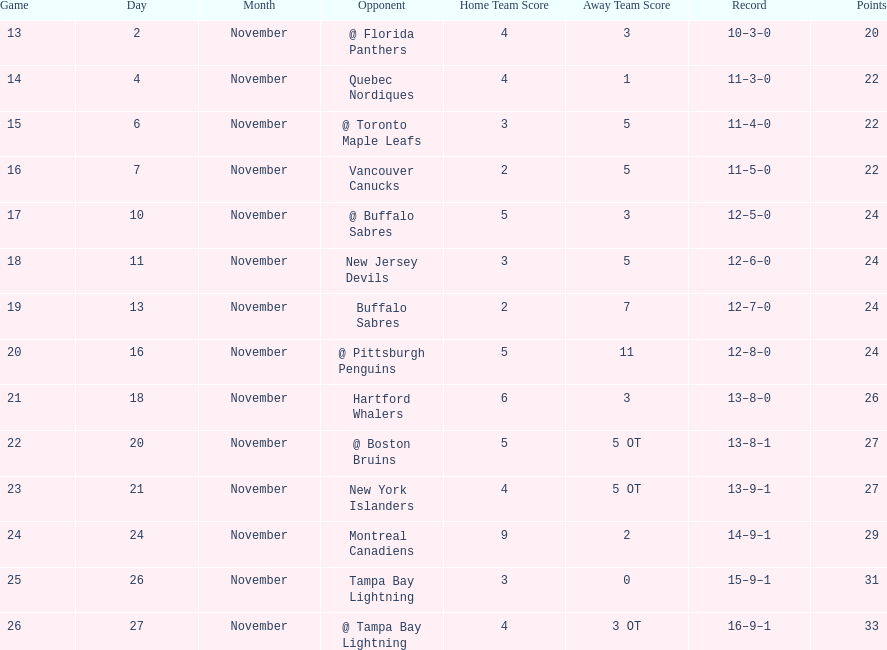Would you mind parsing the complete table? {'header': ['Game', 'Day', 'Month', 'Opponent', 'Home Team Score', 'Away Team Score', 'Record', 'Points'], 'rows': [['13', '2', 'November', '@ Florida Panthers', '4', '3', '10–3–0', '20'], ['14', '4', 'November', 'Quebec Nordiques', '4', '1', '11–3–0', '22'], ['15', '6', 'November', '@ Toronto Maple Leafs', '3', '5', '11–4–0', '22'], ['16', '7', 'November', 'Vancouver Canucks', '2', '5', '11–5–0', '22'], ['17', '10', 'November', '@ Buffalo Sabres', '5', '3', '12–5–0', '24'], ['18', '11', 'November', 'New Jersey Devils', '3', '5', '12–6–0', '24'], ['19', '13', 'November', 'Buffalo Sabres', '2', '7', '12–7–0', '24'], ['20', '16', 'November', '@ Pittsburgh Penguins', '5', '11', '12–8–0', '24'], ['21', '18', 'November', 'Hartford Whalers', '6', '3', '13–8–0', '26'], ['22', '20', 'November', '@ Boston Bruins', '5', '5 OT', '13–8–1', '27'], ['23', '21', 'November', 'New York Islanders', '4', '5 OT', '13–9–1', '27'], ['24', '24', 'November', 'Montreal Canadiens', '9', '2', '14–9–1', '29'], ['25', '26', 'November', 'Tampa Bay Lightning', '3', '0', '15–9–1', '31'], ['26', '27', 'November', '@ Tampa Bay Lightning', '4', '3 OT', '16–9–1', '33']]} The 1993-1994 flyers missed the playoffs again. how many consecutive seasons up until 93-94 did the flyers miss the playoffs? 5. 